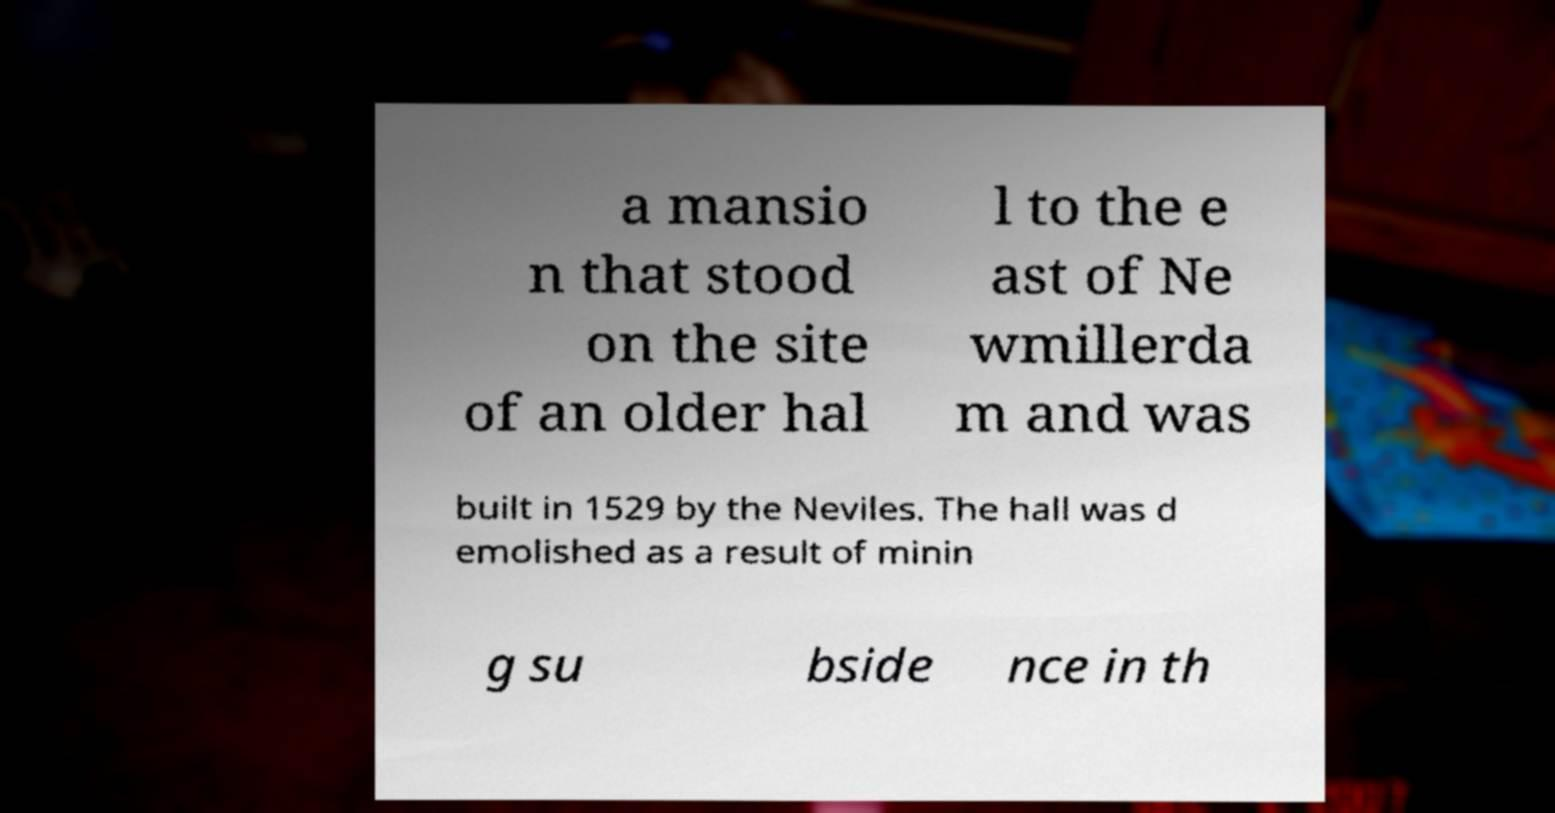Please read and relay the text visible in this image. What does it say? a mansio n that stood on the site of an older hal l to the e ast of Ne wmillerda m and was built in 1529 by the Neviles. The hall was d emolished as a result of minin g su bside nce in th 